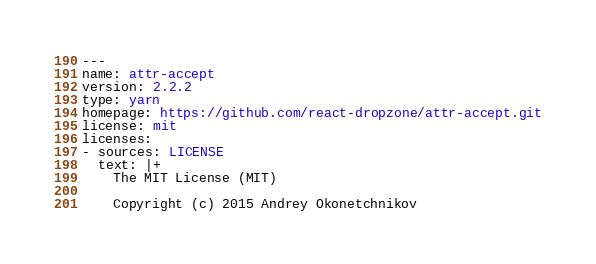Convert code to text. <code><loc_0><loc_0><loc_500><loc_500><_YAML_>---
name: attr-accept
version: 2.2.2
type: yarn
homepage: https://github.com/react-dropzone/attr-accept.git
license: mit
licenses:
- sources: LICENSE
  text: |+
    The MIT License (MIT)

    Copyright (c) 2015 Andrey Okonetchnikov
</code> 